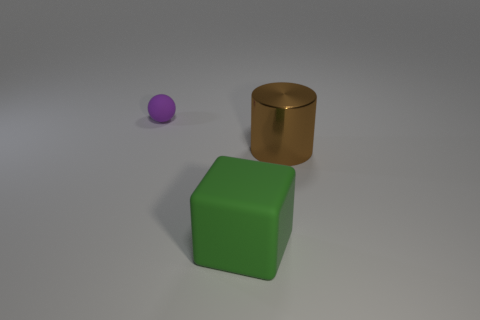Is there any other thing that has the same material as the large green thing?
Offer a terse response. Yes. Are the green object and the small object that is on the left side of the block made of the same material?
Give a very brief answer. Yes. What shape is the matte thing that is right of the matte object to the left of the large green cube?
Make the answer very short. Cube. How many small objects are brown cylinders or cubes?
Give a very brief answer. 0. How many green objects have the same shape as the purple object?
Offer a terse response. 0. Does the tiny purple object have the same shape as the rubber object that is on the right side of the small purple object?
Your answer should be compact. No. What number of big brown shiny cylinders are to the right of the purple matte thing?
Give a very brief answer. 1. Are there any other brown metallic cylinders of the same size as the brown cylinder?
Make the answer very short. No. There is a large thing that is in front of the cylinder; does it have the same shape as the small purple matte object?
Your answer should be compact. No. The small rubber ball has what color?
Make the answer very short. Purple. 